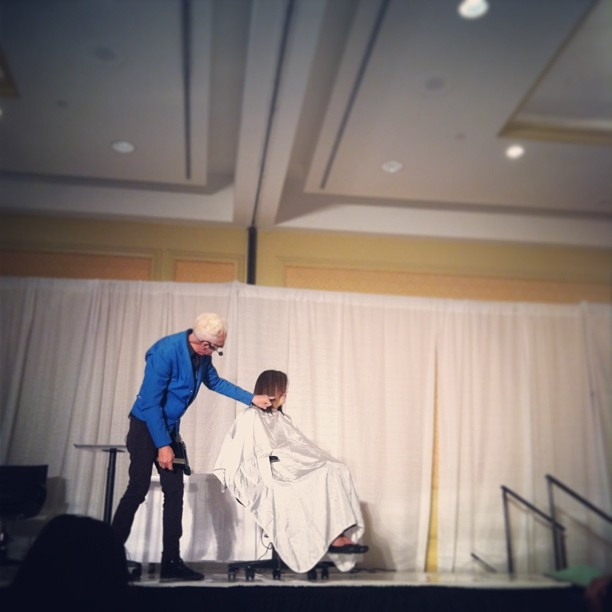Describe the objects in this image and their specific colors. I can see people in black, blue, darkgray, and pink tones, people in black and gray tones, chair in black and gray tones, chair in black and gray tones, and people in black and brown tones in this image. 